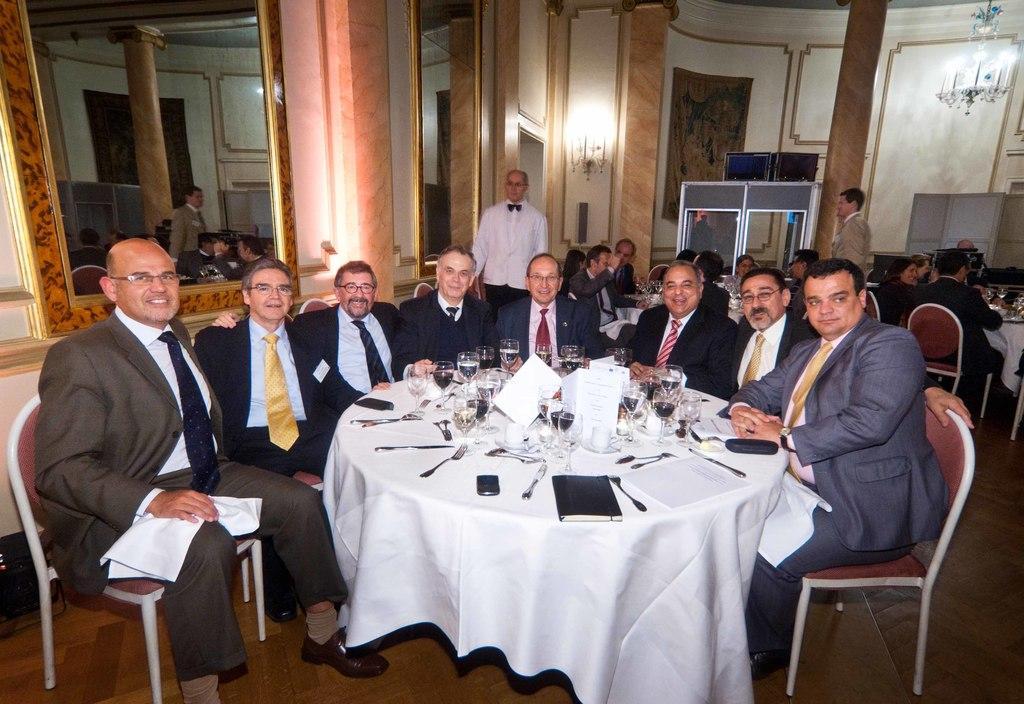How would you summarize this image in a sentence or two? This is a picture taken in a room, there are a group of people sitting on chairs in front of these people there is a table covered with a white cloth on the table there are mobile, knife, fork, spoon, book, paper, glasses, box and board. Behind the people a man in white shirt was standing on the floor, and a wall on the wall there is a mirror and a lights. 